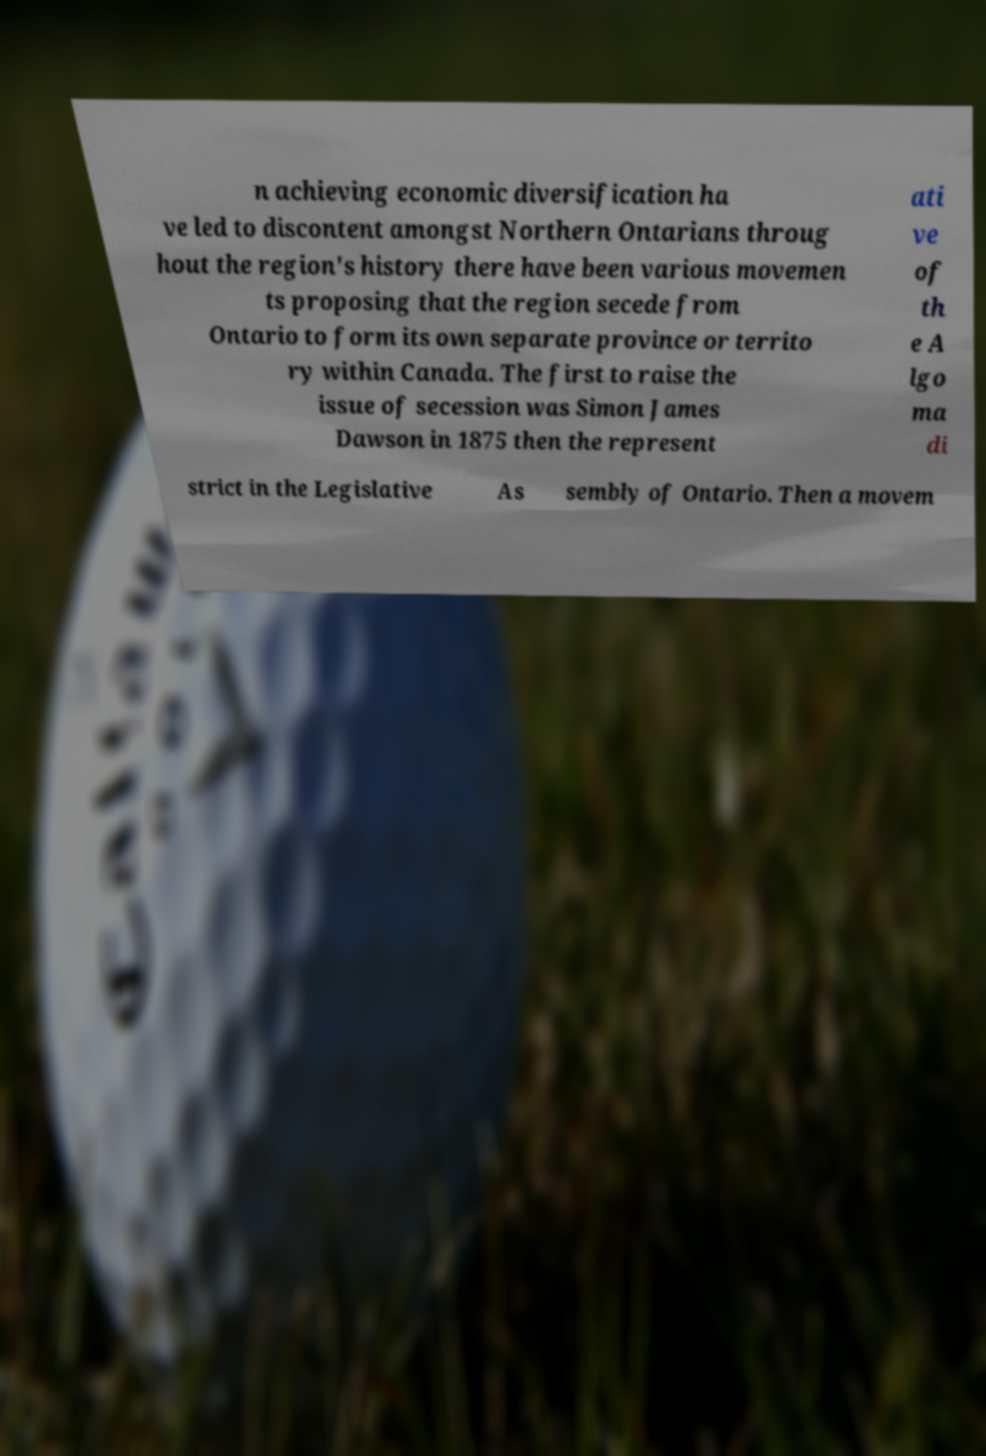What messages or text are displayed in this image? I need them in a readable, typed format. n achieving economic diversification ha ve led to discontent amongst Northern Ontarians throug hout the region's history there have been various movemen ts proposing that the region secede from Ontario to form its own separate province or territo ry within Canada. The first to raise the issue of secession was Simon James Dawson in 1875 then the represent ati ve of th e A lgo ma di strict in the Legislative As sembly of Ontario. Then a movem 